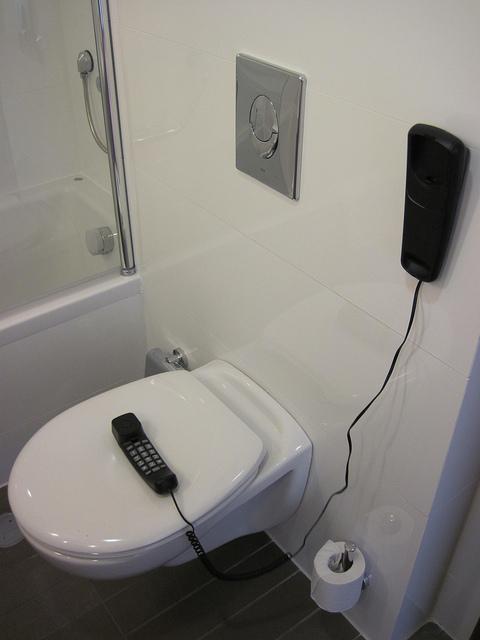Which room is this?
Answer briefly. Bathroom. Did someone forget to hang up the phone?
Give a very brief answer. Yes. Where is this?
Answer briefly. Bathroom. Is the toilet paper ripped evenly?
Be succinct. Yes. 